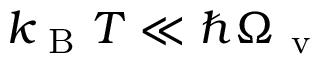Convert formula to latex. <formula><loc_0><loc_0><loc_500><loc_500>k _ { B } T \ll \hbar { \Omega } _ { v }</formula> 